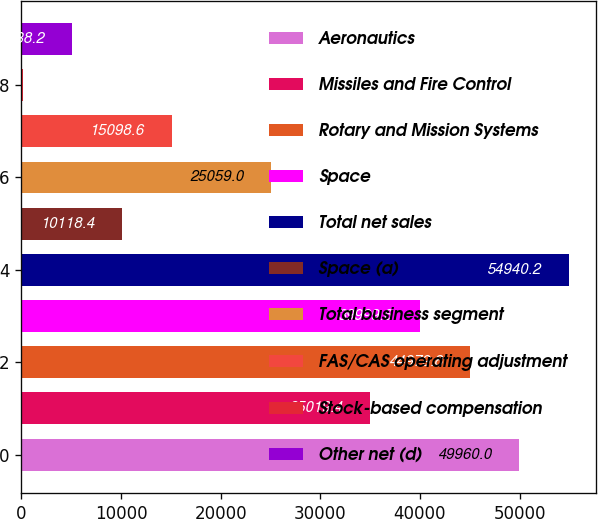<chart> <loc_0><loc_0><loc_500><loc_500><bar_chart><fcel>Aeronautics<fcel>Missiles and Fire Control<fcel>Rotary and Mission Systems<fcel>Space<fcel>Total net sales<fcel>Space (a)<fcel>Total business segment<fcel>FAS/CAS operating adjustment<fcel>Stock-based compensation<fcel>Other net (d)<nl><fcel>49960<fcel>35019.4<fcel>44979.8<fcel>39999.6<fcel>54940.2<fcel>10118.4<fcel>25059<fcel>15098.6<fcel>158<fcel>5138.2<nl></chart> 